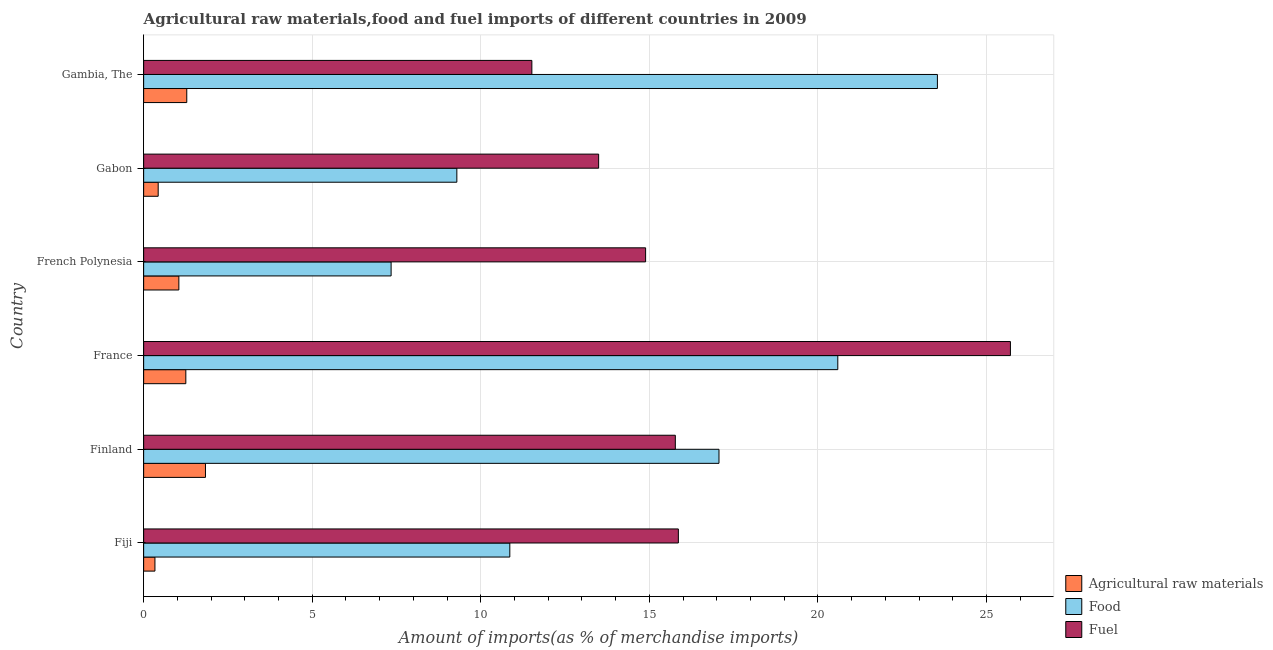How many groups of bars are there?
Offer a very short reply. 6. Are the number of bars per tick equal to the number of legend labels?
Provide a short and direct response. Yes. Are the number of bars on each tick of the Y-axis equal?
Provide a short and direct response. Yes. What is the label of the 3rd group of bars from the top?
Keep it short and to the point. French Polynesia. What is the percentage of food imports in Fiji?
Offer a terse response. 10.86. Across all countries, what is the maximum percentage of fuel imports?
Your response must be concise. 25.71. Across all countries, what is the minimum percentage of raw materials imports?
Your answer should be compact. 0.33. In which country was the percentage of raw materials imports maximum?
Ensure brevity in your answer.  Finland. In which country was the percentage of fuel imports minimum?
Your response must be concise. Gambia, The. What is the total percentage of fuel imports in the graph?
Give a very brief answer. 97.23. What is the difference between the percentage of raw materials imports in Finland and that in Gambia, The?
Ensure brevity in your answer.  0.56. What is the difference between the percentage of food imports in Fiji and the percentage of raw materials imports in Finland?
Offer a terse response. 9.03. What is the average percentage of food imports per country?
Offer a very short reply. 14.78. What is the difference between the percentage of fuel imports and percentage of food imports in Fiji?
Offer a terse response. 5. What is the ratio of the percentage of food imports in Fiji to that in Finland?
Make the answer very short. 0.64. Is the difference between the percentage of fuel imports in Fiji and French Polynesia greater than the difference between the percentage of food imports in Fiji and French Polynesia?
Give a very brief answer. No. What is the difference between the highest and the second highest percentage of raw materials imports?
Your response must be concise. 0.56. What is the difference between the highest and the lowest percentage of fuel imports?
Your answer should be very brief. 14.19. In how many countries, is the percentage of raw materials imports greater than the average percentage of raw materials imports taken over all countries?
Your answer should be very brief. 4. Is the sum of the percentage of food imports in Finland and French Polynesia greater than the maximum percentage of raw materials imports across all countries?
Make the answer very short. Yes. What does the 3rd bar from the top in Finland represents?
Keep it short and to the point. Agricultural raw materials. What does the 3rd bar from the bottom in Fiji represents?
Provide a succinct answer. Fuel. Are all the bars in the graph horizontal?
Ensure brevity in your answer.  Yes. How many countries are there in the graph?
Offer a terse response. 6. Are the values on the major ticks of X-axis written in scientific E-notation?
Provide a succinct answer. No. Does the graph contain any zero values?
Your answer should be compact. No. How many legend labels are there?
Your answer should be compact. 3. What is the title of the graph?
Make the answer very short. Agricultural raw materials,food and fuel imports of different countries in 2009. What is the label or title of the X-axis?
Ensure brevity in your answer.  Amount of imports(as % of merchandise imports). What is the Amount of imports(as % of merchandise imports) in Agricultural raw materials in Fiji?
Your answer should be compact. 0.33. What is the Amount of imports(as % of merchandise imports) of Food in Fiji?
Provide a succinct answer. 10.86. What is the Amount of imports(as % of merchandise imports) in Fuel in Fiji?
Offer a very short reply. 15.86. What is the Amount of imports(as % of merchandise imports) of Agricultural raw materials in Finland?
Provide a succinct answer. 1.83. What is the Amount of imports(as % of merchandise imports) of Food in Finland?
Provide a short and direct response. 17.06. What is the Amount of imports(as % of merchandise imports) of Fuel in Finland?
Keep it short and to the point. 15.77. What is the Amount of imports(as % of merchandise imports) of Agricultural raw materials in France?
Ensure brevity in your answer.  1.25. What is the Amount of imports(as % of merchandise imports) in Food in France?
Keep it short and to the point. 20.59. What is the Amount of imports(as % of merchandise imports) in Fuel in France?
Make the answer very short. 25.71. What is the Amount of imports(as % of merchandise imports) of Agricultural raw materials in French Polynesia?
Provide a short and direct response. 1.04. What is the Amount of imports(as % of merchandise imports) in Food in French Polynesia?
Your response must be concise. 7.34. What is the Amount of imports(as % of merchandise imports) in Fuel in French Polynesia?
Offer a terse response. 14.89. What is the Amount of imports(as % of merchandise imports) in Agricultural raw materials in Gabon?
Your answer should be compact. 0.43. What is the Amount of imports(as % of merchandise imports) in Food in Gabon?
Make the answer very short. 9.29. What is the Amount of imports(as % of merchandise imports) in Fuel in Gabon?
Keep it short and to the point. 13.49. What is the Amount of imports(as % of merchandise imports) in Agricultural raw materials in Gambia, The?
Your answer should be compact. 1.28. What is the Amount of imports(as % of merchandise imports) in Food in Gambia, The?
Provide a succinct answer. 23.54. What is the Amount of imports(as % of merchandise imports) of Fuel in Gambia, The?
Make the answer very short. 11.51. Across all countries, what is the maximum Amount of imports(as % of merchandise imports) in Agricultural raw materials?
Keep it short and to the point. 1.83. Across all countries, what is the maximum Amount of imports(as % of merchandise imports) of Food?
Your answer should be compact. 23.54. Across all countries, what is the maximum Amount of imports(as % of merchandise imports) of Fuel?
Ensure brevity in your answer.  25.71. Across all countries, what is the minimum Amount of imports(as % of merchandise imports) in Agricultural raw materials?
Give a very brief answer. 0.33. Across all countries, what is the minimum Amount of imports(as % of merchandise imports) of Food?
Give a very brief answer. 7.34. Across all countries, what is the minimum Amount of imports(as % of merchandise imports) in Fuel?
Provide a short and direct response. 11.51. What is the total Amount of imports(as % of merchandise imports) of Agricultural raw materials in the graph?
Offer a very short reply. 6.17. What is the total Amount of imports(as % of merchandise imports) of Food in the graph?
Keep it short and to the point. 88.68. What is the total Amount of imports(as % of merchandise imports) in Fuel in the graph?
Offer a terse response. 97.23. What is the difference between the Amount of imports(as % of merchandise imports) in Agricultural raw materials in Fiji and that in Finland?
Give a very brief answer. -1.5. What is the difference between the Amount of imports(as % of merchandise imports) in Food in Fiji and that in Finland?
Provide a short and direct response. -6.2. What is the difference between the Amount of imports(as % of merchandise imports) in Fuel in Fiji and that in Finland?
Provide a short and direct response. 0.09. What is the difference between the Amount of imports(as % of merchandise imports) in Agricultural raw materials in Fiji and that in France?
Offer a terse response. -0.92. What is the difference between the Amount of imports(as % of merchandise imports) of Food in Fiji and that in France?
Offer a terse response. -9.73. What is the difference between the Amount of imports(as % of merchandise imports) of Fuel in Fiji and that in France?
Give a very brief answer. -9.85. What is the difference between the Amount of imports(as % of merchandise imports) in Agricultural raw materials in Fiji and that in French Polynesia?
Provide a succinct answer. -0.71. What is the difference between the Amount of imports(as % of merchandise imports) in Food in Fiji and that in French Polynesia?
Give a very brief answer. 3.52. What is the difference between the Amount of imports(as % of merchandise imports) in Fuel in Fiji and that in French Polynesia?
Your answer should be very brief. 0.97. What is the difference between the Amount of imports(as % of merchandise imports) in Agricultural raw materials in Fiji and that in Gabon?
Make the answer very short. -0.1. What is the difference between the Amount of imports(as % of merchandise imports) of Food in Fiji and that in Gabon?
Make the answer very short. 1.57. What is the difference between the Amount of imports(as % of merchandise imports) in Fuel in Fiji and that in Gabon?
Make the answer very short. 2.36. What is the difference between the Amount of imports(as % of merchandise imports) in Agricultural raw materials in Fiji and that in Gambia, The?
Ensure brevity in your answer.  -0.94. What is the difference between the Amount of imports(as % of merchandise imports) of Food in Fiji and that in Gambia, The?
Provide a short and direct response. -12.68. What is the difference between the Amount of imports(as % of merchandise imports) of Fuel in Fiji and that in Gambia, The?
Offer a terse response. 4.35. What is the difference between the Amount of imports(as % of merchandise imports) in Agricultural raw materials in Finland and that in France?
Offer a terse response. 0.58. What is the difference between the Amount of imports(as % of merchandise imports) of Food in Finland and that in France?
Your answer should be very brief. -3.52. What is the difference between the Amount of imports(as % of merchandise imports) of Fuel in Finland and that in France?
Offer a very short reply. -9.94. What is the difference between the Amount of imports(as % of merchandise imports) in Agricultural raw materials in Finland and that in French Polynesia?
Give a very brief answer. 0.79. What is the difference between the Amount of imports(as % of merchandise imports) of Food in Finland and that in French Polynesia?
Your answer should be very brief. 9.72. What is the difference between the Amount of imports(as % of merchandise imports) of Fuel in Finland and that in French Polynesia?
Offer a terse response. 0.88. What is the difference between the Amount of imports(as % of merchandise imports) of Agricultural raw materials in Finland and that in Gabon?
Offer a very short reply. 1.4. What is the difference between the Amount of imports(as % of merchandise imports) in Food in Finland and that in Gabon?
Provide a short and direct response. 7.77. What is the difference between the Amount of imports(as % of merchandise imports) of Fuel in Finland and that in Gabon?
Keep it short and to the point. 2.27. What is the difference between the Amount of imports(as % of merchandise imports) of Agricultural raw materials in Finland and that in Gambia, The?
Offer a very short reply. 0.55. What is the difference between the Amount of imports(as % of merchandise imports) of Food in Finland and that in Gambia, The?
Give a very brief answer. -6.48. What is the difference between the Amount of imports(as % of merchandise imports) of Fuel in Finland and that in Gambia, The?
Ensure brevity in your answer.  4.26. What is the difference between the Amount of imports(as % of merchandise imports) in Agricultural raw materials in France and that in French Polynesia?
Your answer should be very brief. 0.21. What is the difference between the Amount of imports(as % of merchandise imports) in Food in France and that in French Polynesia?
Ensure brevity in your answer.  13.25. What is the difference between the Amount of imports(as % of merchandise imports) in Fuel in France and that in French Polynesia?
Your answer should be compact. 10.82. What is the difference between the Amount of imports(as % of merchandise imports) of Agricultural raw materials in France and that in Gabon?
Offer a terse response. 0.82. What is the difference between the Amount of imports(as % of merchandise imports) of Food in France and that in Gabon?
Your answer should be very brief. 11.3. What is the difference between the Amount of imports(as % of merchandise imports) in Fuel in France and that in Gabon?
Keep it short and to the point. 12.21. What is the difference between the Amount of imports(as % of merchandise imports) in Agricultural raw materials in France and that in Gambia, The?
Ensure brevity in your answer.  -0.03. What is the difference between the Amount of imports(as % of merchandise imports) in Food in France and that in Gambia, The?
Give a very brief answer. -2.95. What is the difference between the Amount of imports(as % of merchandise imports) of Fuel in France and that in Gambia, The?
Provide a short and direct response. 14.19. What is the difference between the Amount of imports(as % of merchandise imports) of Agricultural raw materials in French Polynesia and that in Gabon?
Provide a short and direct response. 0.61. What is the difference between the Amount of imports(as % of merchandise imports) in Food in French Polynesia and that in Gabon?
Your answer should be very brief. -1.95. What is the difference between the Amount of imports(as % of merchandise imports) of Fuel in French Polynesia and that in Gabon?
Give a very brief answer. 1.39. What is the difference between the Amount of imports(as % of merchandise imports) of Agricultural raw materials in French Polynesia and that in Gambia, The?
Make the answer very short. -0.23. What is the difference between the Amount of imports(as % of merchandise imports) in Food in French Polynesia and that in Gambia, The?
Keep it short and to the point. -16.2. What is the difference between the Amount of imports(as % of merchandise imports) of Fuel in French Polynesia and that in Gambia, The?
Your answer should be compact. 3.37. What is the difference between the Amount of imports(as % of merchandise imports) in Agricultural raw materials in Gabon and that in Gambia, The?
Make the answer very short. -0.85. What is the difference between the Amount of imports(as % of merchandise imports) of Food in Gabon and that in Gambia, The?
Offer a terse response. -14.25. What is the difference between the Amount of imports(as % of merchandise imports) of Fuel in Gabon and that in Gambia, The?
Your answer should be compact. 1.98. What is the difference between the Amount of imports(as % of merchandise imports) in Agricultural raw materials in Fiji and the Amount of imports(as % of merchandise imports) in Food in Finland?
Offer a terse response. -16.73. What is the difference between the Amount of imports(as % of merchandise imports) in Agricultural raw materials in Fiji and the Amount of imports(as % of merchandise imports) in Fuel in Finland?
Make the answer very short. -15.43. What is the difference between the Amount of imports(as % of merchandise imports) of Food in Fiji and the Amount of imports(as % of merchandise imports) of Fuel in Finland?
Your response must be concise. -4.91. What is the difference between the Amount of imports(as % of merchandise imports) of Agricultural raw materials in Fiji and the Amount of imports(as % of merchandise imports) of Food in France?
Keep it short and to the point. -20.25. What is the difference between the Amount of imports(as % of merchandise imports) in Agricultural raw materials in Fiji and the Amount of imports(as % of merchandise imports) in Fuel in France?
Provide a succinct answer. -25.37. What is the difference between the Amount of imports(as % of merchandise imports) in Food in Fiji and the Amount of imports(as % of merchandise imports) in Fuel in France?
Offer a terse response. -14.85. What is the difference between the Amount of imports(as % of merchandise imports) in Agricultural raw materials in Fiji and the Amount of imports(as % of merchandise imports) in Food in French Polynesia?
Give a very brief answer. -7. What is the difference between the Amount of imports(as % of merchandise imports) in Agricultural raw materials in Fiji and the Amount of imports(as % of merchandise imports) in Fuel in French Polynesia?
Provide a succinct answer. -14.55. What is the difference between the Amount of imports(as % of merchandise imports) in Food in Fiji and the Amount of imports(as % of merchandise imports) in Fuel in French Polynesia?
Offer a very short reply. -4.03. What is the difference between the Amount of imports(as % of merchandise imports) in Agricultural raw materials in Fiji and the Amount of imports(as % of merchandise imports) in Food in Gabon?
Your answer should be very brief. -8.95. What is the difference between the Amount of imports(as % of merchandise imports) of Agricultural raw materials in Fiji and the Amount of imports(as % of merchandise imports) of Fuel in Gabon?
Your answer should be very brief. -13.16. What is the difference between the Amount of imports(as % of merchandise imports) of Food in Fiji and the Amount of imports(as % of merchandise imports) of Fuel in Gabon?
Your answer should be compact. -2.63. What is the difference between the Amount of imports(as % of merchandise imports) of Agricultural raw materials in Fiji and the Amount of imports(as % of merchandise imports) of Food in Gambia, The?
Offer a terse response. -23.21. What is the difference between the Amount of imports(as % of merchandise imports) in Agricultural raw materials in Fiji and the Amount of imports(as % of merchandise imports) in Fuel in Gambia, The?
Provide a succinct answer. -11.18. What is the difference between the Amount of imports(as % of merchandise imports) in Food in Fiji and the Amount of imports(as % of merchandise imports) in Fuel in Gambia, The?
Your response must be concise. -0.65. What is the difference between the Amount of imports(as % of merchandise imports) of Agricultural raw materials in Finland and the Amount of imports(as % of merchandise imports) of Food in France?
Provide a short and direct response. -18.75. What is the difference between the Amount of imports(as % of merchandise imports) of Agricultural raw materials in Finland and the Amount of imports(as % of merchandise imports) of Fuel in France?
Provide a short and direct response. -23.87. What is the difference between the Amount of imports(as % of merchandise imports) of Food in Finland and the Amount of imports(as % of merchandise imports) of Fuel in France?
Your answer should be very brief. -8.64. What is the difference between the Amount of imports(as % of merchandise imports) of Agricultural raw materials in Finland and the Amount of imports(as % of merchandise imports) of Food in French Polynesia?
Your answer should be compact. -5.51. What is the difference between the Amount of imports(as % of merchandise imports) in Agricultural raw materials in Finland and the Amount of imports(as % of merchandise imports) in Fuel in French Polynesia?
Keep it short and to the point. -13.05. What is the difference between the Amount of imports(as % of merchandise imports) in Food in Finland and the Amount of imports(as % of merchandise imports) in Fuel in French Polynesia?
Offer a terse response. 2.18. What is the difference between the Amount of imports(as % of merchandise imports) in Agricultural raw materials in Finland and the Amount of imports(as % of merchandise imports) in Food in Gabon?
Provide a succinct answer. -7.46. What is the difference between the Amount of imports(as % of merchandise imports) in Agricultural raw materials in Finland and the Amount of imports(as % of merchandise imports) in Fuel in Gabon?
Your response must be concise. -11.66. What is the difference between the Amount of imports(as % of merchandise imports) in Food in Finland and the Amount of imports(as % of merchandise imports) in Fuel in Gabon?
Offer a terse response. 3.57. What is the difference between the Amount of imports(as % of merchandise imports) of Agricultural raw materials in Finland and the Amount of imports(as % of merchandise imports) of Food in Gambia, The?
Your answer should be very brief. -21.71. What is the difference between the Amount of imports(as % of merchandise imports) in Agricultural raw materials in Finland and the Amount of imports(as % of merchandise imports) in Fuel in Gambia, The?
Make the answer very short. -9.68. What is the difference between the Amount of imports(as % of merchandise imports) in Food in Finland and the Amount of imports(as % of merchandise imports) in Fuel in Gambia, The?
Provide a succinct answer. 5.55. What is the difference between the Amount of imports(as % of merchandise imports) in Agricultural raw materials in France and the Amount of imports(as % of merchandise imports) in Food in French Polynesia?
Your answer should be very brief. -6.09. What is the difference between the Amount of imports(as % of merchandise imports) in Agricultural raw materials in France and the Amount of imports(as % of merchandise imports) in Fuel in French Polynesia?
Give a very brief answer. -13.64. What is the difference between the Amount of imports(as % of merchandise imports) of Food in France and the Amount of imports(as % of merchandise imports) of Fuel in French Polynesia?
Give a very brief answer. 5.7. What is the difference between the Amount of imports(as % of merchandise imports) of Agricultural raw materials in France and the Amount of imports(as % of merchandise imports) of Food in Gabon?
Ensure brevity in your answer.  -8.04. What is the difference between the Amount of imports(as % of merchandise imports) in Agricultural raw materials in France and the Amount of imports(as % of merchandise imports) in Fuel in Gabon?
Provide a short and direct response. -12.24. What is the difference between the Amount of imports(as % of merchandise imports) of Food in France and the Amount of imports(as % of merchandise imports) of Fuel in Gabon?
Provide a succinct answer. 7.09. What is the difference between the Amount of imports(as % of merchandise imports) in Agricultural raw materials in France and the Amount of imports(as % of merchandise imports) in Food in Gambia, The?
Give a very brief answer. -22.29. What is the difference between the Amount of imports(as % of merchandise imports) of Agricultural raw materials in France and the Amount of imports(as % of merchandise imports) of Fuel in Gambia, The?
Give a very brief answer. -10.26. What is the difference between the Amount of imports(as % of merchandise imports) in Food in France and the Amount of imports(as % of merchandise imports) in Fuel in Gambia, The?
Your answer should be very brief. 9.07. What is the difference between the Amount of imports(as % of merchandise imports) in Agricultural raw materials in French Polynesia and the Amount of imports(as % of merchandise imports) in Food in Gabon?
Your answer should be very brief. -8.24. What is the difference between the Amount of imports(as % of merchandise imports) in Agricultural raw materials in French Polynesia and the Amount of imports(as % of merchandise imports) in Fuel in Gabon?
Keep it short and to the point. -12.45. What is the difference between the Amount of imports(as % of merchandise imports) in Food in French Polynesia and the Amount of imports(as % of merchandise imports) in Fuel in Gabon?
Offer a terse response. -6.16. What is the difference between the Amount of imports(as % of merchandise imports) in Agricultural raw materials in French Polynesia and the Amount of imports(as % of merchandise imports) in Food in Gambia, The?
Your answer should be compact. -22.5. What is the difference between the Amount of imports(as % of merchandise imports) of Agricultural raw materials in French Polynesia and the Amount of imports(as % of merchandise imports) of Fuel in Gambia, The?
Your response must be concise. -10.47. What is the difference between the Amount of imports(as % of merchandise imports) of Food in French Polynesia and the Amount of imports(as % of merchandise imports) of Fuel in Gambia, The?
Keep it short and to the point. -4.17. What is the difference between the Amount of imports(as % of merchandise imports) in Agricultural raw materials in Gabon and the Amount of imports(as % of merchandise imports) in Food in Gambia, The?
Ensure brevity in your answer.  -23.11. What is the difference between the Amount of imports(as % of merchandise imports) in Agricultural raw materials in Gabon and the Amount of imports(as % of merchandise imports) in Fuel in Gambia, The?
Your answer should be compact. -11.08. What is the difference between the Amount of imports(as % of merchandise imports) of Food in Gabon and the Amount of imports(as % of merchandise imports) of Fuel in Gambia, The?
Make the answer very short. -2.22. What is the average Amount of imports(as % of merchandise imports) in Agricultural raw materials per country?
Offer a very short reply. 1.03. What is the average Amount of imports(as % of merchandise imports) of Food per country?
Give a very brief answer. 14.78. What is the average Amount of imports(as % of merchandise imports) of Fuel per country?
Your answer should be compact. 16.21. What is the difference between the Amount of imports(as % of merchandise imports) in Agricultural raw materials and Amount of imports(as % of merchandise imports) in Food in Fiji?
Make the answer very short. -10.53. What is the difference between the Amount of imports(as % of merchandise imports) in Agricultural raw materials and Amount of imports(as % of merchandise imports) in Fuel in Fiji?
Keep it short and to the point. -15.52. What is the difference between the Amount of imports(as % of merchandise imports) in Food and Amount of imports(as % of merchandise imports) in Fuel in Fiji?
Your answer should be very brief. -5. What is the difference between the Amount of imports(as % of merchandise imports) in Agricultural raw materials and Amount of imports(as % of merchandise imports) in Food in Finland?
Your answer should be compact. -15.23. What is the difference between the Amount of imports(as % of merchandise imports) of Agricultural raw materials and Amount of imports(as % of merchandise imports) of Fuel in Finland?
Offer a terse response. -13.94. What is the difference between the Amount of imports(as % of merchandise imports) of Food and Amount of imports(as % of merchandise imports) of Fuel in Finland?
Provide a succinct answer. 1.29. What is the difference between the Amount of imports(as % of merchandise imports) in Agricultural raw materials and Amount of imports(as % of merchandise imports) in Food in France?
Give a very brief answer. -19.34. What is the difference between the Amount of imports(as % of merchandise imports) of Agricultural raw materials and Amount of imports(as % of merchandise imports) of Fuel in France?
Ensure brevity in your answer.  -24.46. What is the difference between the Amount of imports(as % of merchandise imports) of Food and Amount of imports(as % of merchandise imports) of Fuel in France?
Keep it short and to the point. -5.12. What is the difference between the Amount of imports(as % of merchandise imports) in Agricultural raw materials and Amount of imports(as % of merchandise imports) in Food in French Polynesia?
Provide a short and direct response. -6.3. What is the difference between the Amount of imports(as % of merchandise imports) of Agricultural raw materials and Amount of imports(as % of merchandise imports) of Fuel in French Polynesia?
Your response must be concise. -13.84. What is the difference between the Amount of imports(as % of merchandise imports) of Food and Amount of imports(as % of merchandise imports) of Fuel in French Polynesia?
Make the answer very short. -7.55. What is the difference between the Amount of imports(as % of merchandise imports) of Agricultural raw materials and Amount of imports(as % of merchandise imports) of Food in Gabon?
Give a very brief answer. -8.86. What is the difference between the Amount of imports(as % of merchandise imports) in Agricultural raw materials and Amount of imports(as % of merchandise imports) in Fuel in Gabon?
Provide a short and direct response. -13.06. What is the difference between the Amount of imports(as % of merchandise imports) of Food and Amount of imports(as % of merchandise imports) of Fuel in Gabon?
Your answer should be very brief. -4.21. What is the difference between the Amount of imports(as % of merchandise imports) of Agricultural raw materials and Amount of imports(as % of merchandise imports) of Food in Gambia, The?
Give a very brief answer. -22.26. What is the difference between the Amount of imports(as % of merchandise imports) of Agricultural raw materials and Amount of imports(as % of merchandise imports) of Fuel in Gambia, The?
Ensure brevity in your answer.  -10.23. What is the difference between the Amount of imports(as % of merchandise imports) in Food and Amount of imports(as % of merchandise imports) in Fuel in Gambia, The?
Provide a short and direct response. 12.03. What is the ratio of the Amount of imports(as % of merchandise imports) in Agricultural raw materials in Fiji to that in Finland?
Your answer should be compact. 0.18. What is the ratio of the Amount of imports(as % of merchandise imports) of Food in Fiji to that in Finland?
Provide a succinct answer. 0.64. What is the ratio of the Amount of imports(as % of merchandise imports) of Agricultural raw materials in Fiji to that in France?
Provide a short and direct response. 0.27. What is the ratio of the Amount of imports(as % of merchandise imports) in Food in Fiji to that in France?
Offer a terse response. 0.53. What is the ratio of the Amount of imports(as % of merchandise imports) in Fuel in Fiji to that in France?
Provide a succinct answer. 0.62. What is the ratio of the Amount of imports(as % of merchandise imports) in Agricultural raw materials in Fiji to that in French Polynesia?
Make the answer very short. 0.32. What is the ratio of the Amount of imports(as % of merchandise imports) in Food in Fiji to that in French Polynesia?
Ensure brevity in your answer.  1.48. What is the ratio of the Amount of imports(as % of merchandise imports) of Fuel in Fiji to that in French Polynesia?
Offer a very short reply. 1.07. What is the ratio of the Amount of imports(as % of merchandise imports) of Agricultural raw materials in Fiji to that in Gabon?
Offer a terse response. 0.78. What is the ratio of the Amount of imports(as % of merchandise imports) of Food in Fiji to that in Gabon?
Give a very brief answer. 1.17. What is the ratio of the Amount of imports(as % of merchandise imports) of Fuel in Fiji to that in Gabon?
Make the answer very short. 1.18. What is the ratio of the Amount of imports(as % of merchandise imports) of Agricultural raw materials in Fiji to that in Gambia, The?
Provide a short and direct response. 0.26. What is the ratio of the Amount of imports(as % of merchandise imports) in Food in Fiji to that in Gambia, The?
Offer a very short reply. 0.46. What is the ratio of the Amount of imports(as % of merchandise imports) of Fuel in Fiji to that in Gambia, The?
Offer a terse response. 1.38. What is the ratio of the Amount of imports(as % of merchandise imports) of Agricultural raw materials in Finland to that in France?
Offer a very short reply. 1.47. What is the ratio of the Amount of imports(as % of merchandise imports) in Food in Finland to that in France?
Ensure brevity in your answer.  0.83. What is the ratio of the Amount of imports(as % of merchandise imports) of Fuel in Finland to that in France?
Ensure brevity in your answer.  0.61. What is the ratio of the Amount of imports(as % of merchandise imports) in Agricultural raw materials in Finland to that in French Polynesia?
Give a very brief answer. 1.76. What is the ratio of the Amount of imports(as % of merchandise imports) of Food in Finland to that in French Polynesia?
Your answer should be compact. 2.32. What is the ratio of the Amount of imports(as % of merchandise imports) of Fuel in Finland to that in French Polynesia?
Your answer should be very brief. 1.06. What is the ratio of the Amount of imports(as % of merchandise imports) in Agricultural raw materials in Finland to that in Gabon?
Ensure brevity in your answer.  4.25. What is the ratio of the Amount of imports(as % of merchandise imports) in Food in Finland to that in Gabon?
Your response must be concise. 1.84. What is the ratio of the Amount of imports(as % of merchandise imports) of Fuel in Finland to that in Gabon?
Your answer should be very brief. 1.17. What is the ratio of the Amount of imports(as % of merchandise imports) of Agricultural raw materials in Finland to that in Gambia, The?
Make the answer very short. 1.43. What is the ratio of the Amount of imports(as % of merchandise imports) in Food in Finland to that in Gambia, The?
Give a very brief answer. 0.72. What is the ratio of the Amount of imports(as % of merchandise imports) in Fuel in Finland to that in Gambia, The?
Give a very brief answer. 1.37. What is the ratio of the Amount of imports(as % of merchandise imports) in Agricultural raw materials in France to that in French Polynesia?
Your response must be concise. 1.2. What is the ratio of the Amount of imports(as % of merchandise imports) of Food in France to that in French Polynesia?
Offer a terse response. 2.81. What is the ratio of the Amount of imports(as % of merchandise imports) in Fuel in France to that in French Polynesia?
Offer a very short reply. 1.73. What is the ratio of the Amount of imports(as % of merchandise imports) in Agricultural raw materials in France to that in Gabon?
Ensure brevity in your answer.  2.9. What is the ratio of the Amount of imports(as % of merchandise imports) in Food in France to that in Gabon?
Provide a short and direct response. 2.22. What is the ratio of the Amount of imports(as % of merchandise imports) of Fuel in France to that in Gabon?
Your answer should be compact. 1.91. What is the ratio of the Amount of imports(as % of merchandise imports) in Agricultural raw materials in France to that in Gambia, The?
Give a very brief answer. 0.98. What is the ratio of the Amount of imports(as % of merchandise imports) in Food in France to that in Gambia, The?
Keep it short and to the point. 0.87. What is the ratio of the Amount of imports(as % of merchandise imports) in Fuel in France to that in Gambia, The?
Offer a terse response. 2.23. What is the ratio of the Amount of imports(as % of merchandise imports) of Agricultural raw materials in French Polynesia to that in Gabon?
Provide a succinct answer. 2.42. What is the ratio of the Amount of imports(as % of merchandise imports) of Food in French Polynesia to that in Gabon?
Keep it short and to the point. 0.79. What is the ratio of the Amount of imports(as % of merchandise imports) of Fuel in French Polynesia to that in Gabon?
Give a very brief answer. 1.1. What is the ratio of the Amount of imports(as % of merchandise imports) in Agricultural raw materials in French Polynesia to that in Gambia, The?
Give a very brief answer. 0.82. What is the ratio of the Amount of imports(as % of merchandise imports) in Food in French Polynesia to that in Gambia, The?
Offer a very short reply. 0.31. What is the ratio of the Amount of imports(as % of merchandise imports) of Fuel in French Polynesia to that in Gambia, The?
Ensure brevity in your answer.  1.29. What is the ratio of the Amount of imports(as % of merchandise imports) in Agricultural raw materials in Gabon to that in Gambia, The?
Your answer should be very brief. 0.34. What is the ratio of the Amount of imports(as % of merchandise imports) of Food in Gabon to that in Gambia, The?
Your answer should be compact. 0.39. What is the ratio of the Amount of imports(as % of merchandise imports) of Fuel in Gabon to that in Gambia, The?
Your response must be concise. 1.17. What is the difference between the highest and the second highest Amount of imports(as % of merchandise imports) in Agricultural raw materials?
Offer a terse response. 0.55. What is the difference between the highest and the second highest Amount of imports(as % of merchandise imports) in Food?
Your response must be concise. 2.95. What is the difference between the highest and the second highest Amount of imports(as % of merchandise imports) of Fuel?
Ensure brevity in your answer.  9.85. What is the difference between the highest and the lowest Amount of imports(as % of merchandise imports) of Agricultural raw materials?
Your response must be concise. 1.5. What is the difference between the highest and the lowest Amount of imports(as % of merchandise imports) in Food?
Provide a short and direct response. 16.2. What is the difference between the highest and the lowest Amount of imports(as % of merchandise imports) in Fuel?
Make the answer very short. 14.19. 